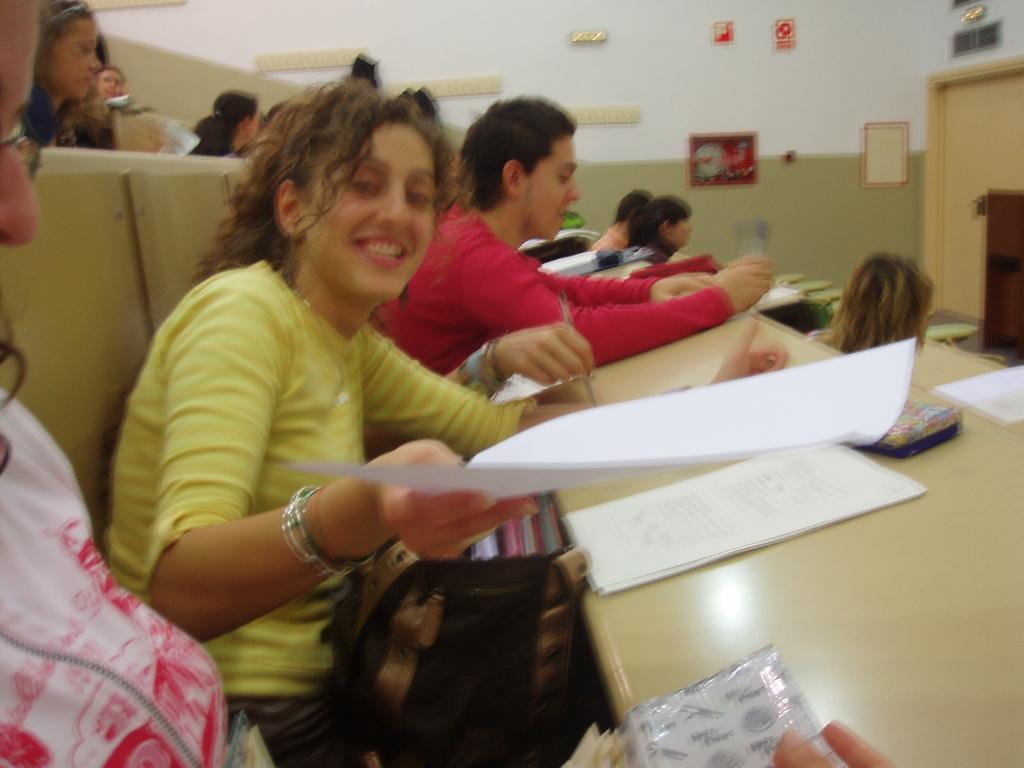Can you describe this image briefly? In this image there are benches and we can see people sitting. The lady sitting in the center is holding a paper. We can see papers and an object placed on the bench. In the background there is a wall and we can see boards placed on the wall. 